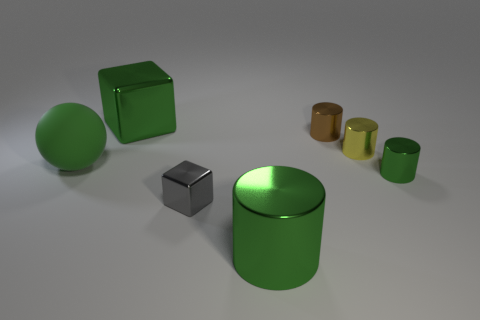Are the sizes of the objects indicative of their real-world counterparts? The objects in the image seem to be scaled for illustrative purposes rather than reflecting their real-world sizes. For example, the gray cube appears to be the same size as the smaller green cylinder, which, in reality, would likely differ if these were common objects like a container and a dice. 